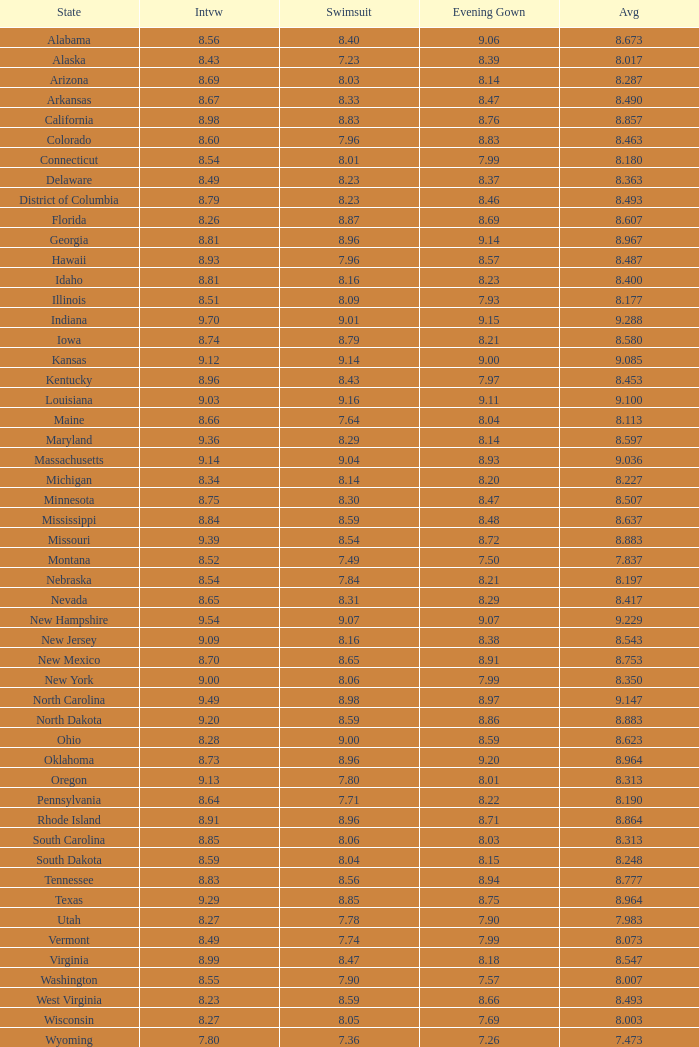Name the total number of swimsuits for evening gowns less than 8.21 and average of 8.453 with interview less than 9.09 1.0. 